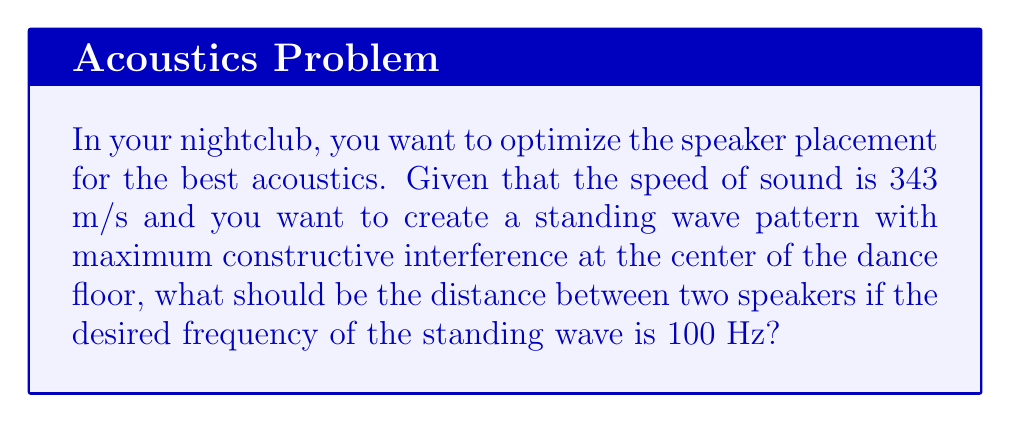Could you help me with this problem? To solve this problem, we need to follow these steps:

1. Recall the relationship between wavelength ($\lambda$), frequency ($f$), and speed of sound ($v$):
   $$v = f\lambda$$

2. Rearrange the equation to solve for wavelength:
   $$\lambda = \frac{v}{f}$$

3. Substitute the given values:
   $v = 343$ m/s (speed of sound)
   $f = 100$ Hz (desired frequency)
   
   $$\lambda = \frac{343 \text{ m/s}}{100 \text{ Hz}} = 3.43 \text{ m}$$

4. For maximum constructive interference at the center, the distance between speakers should be half of the wavelength:
   $$\text{Distance} = \frac{\lambda}{2} = \frac{3.43 \text{ m}}{2} = 1.715 \text{ m}$$

5. Round to a practical measurement:
   $$\text{Distance} \approx 1.72 \text{ m}$$
Answer: 1.72 m 